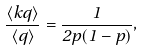<formula> <loc_0><loc_0><loc_500><loc_500>\frac { \langle k q \rangle } { \langle q \rangle } = \frac { 1 } { 2 p ( 1 - p ) } ,</formula> 